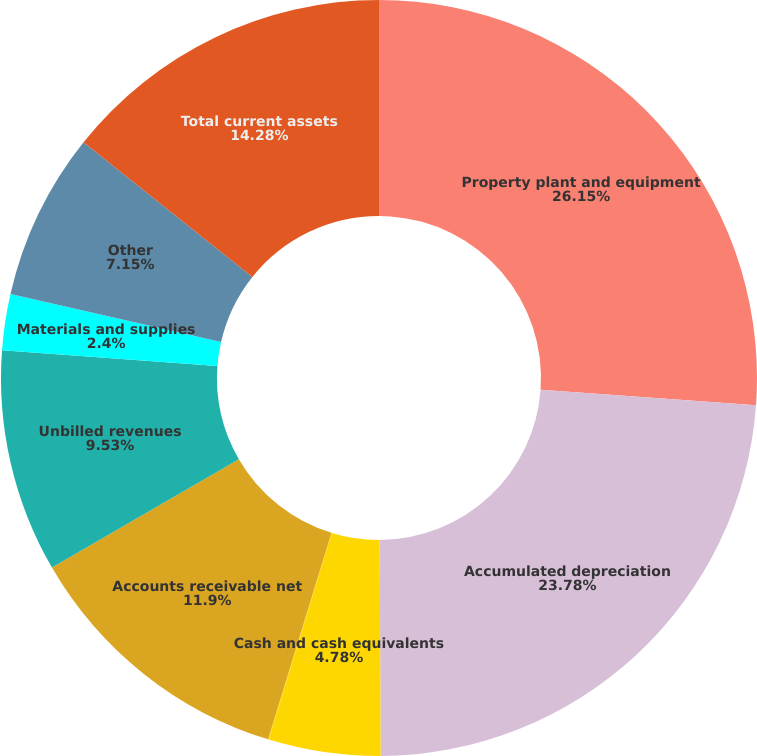<chart> <loc_0><loc_0><loc_500><loc_500><pie_chart><fcel>Property plant and equipment<fcel>Accumulated depreciation<fcel>Cash and cash equivalents<fcel>Restricted funds<fcel>Accounts receivable net<fcel>Unbilled revenues<fcel>Materials and supplies<fcel>Other<fcel>Total current assets<nl><fcel>26.15%<fcel>23.78%<fcel>4.78%<fcel>0.03%<fcel>11.9%<fcel>9.53%<fcel>2.4%<fcel>7.15%<fcel>14.28%<nl></chart> 